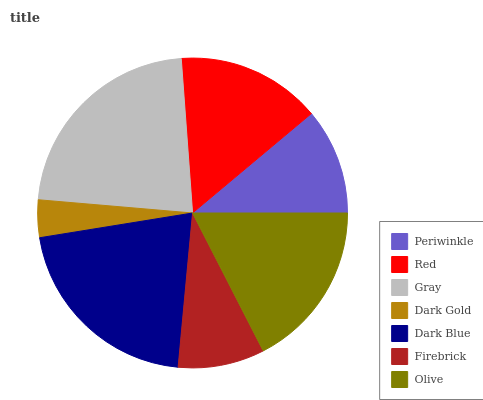Is Dark Gold the minimum?
Answer yes or no. Yes. Is Gray the maximum?
Answer yes or no. Yes. Is Red the minimum?
Answer yes or no. No. Is Red the maximum?
Answer yes or no. No. Is Red greater than Periwinkle?
Answer yes or no. Yes. Is Periwinkle less than Red?
Answer yes or no. Yes. Is Periwinkle greater than Red?
Answer yes or no. No. Is Red less than Periwinkle?
Answer yes or no. No. Is Red the high median?
Answer yes or no. Yes. Is Red the low median?
Answer yes or no. Yes. Is Olive the high median?
Answer yes or no. No. Is Periwinkle the low median?
Answer yes or no. No. 